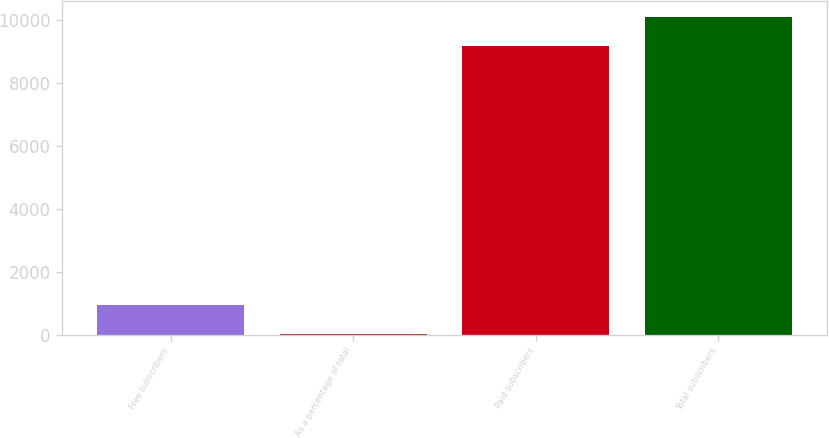Convert chart to OTSL. <chart><loc_0><loc_0><loc_500><loc_500><bar_chart><fcel>Free subscribers<fcel>As a percentage of total<fcel>Paid subscribers<fcel>Total subscribers<nl><fcel>941.16<fcel>2.4<fcel>9164<fcel>10102.8<nl></chart> 